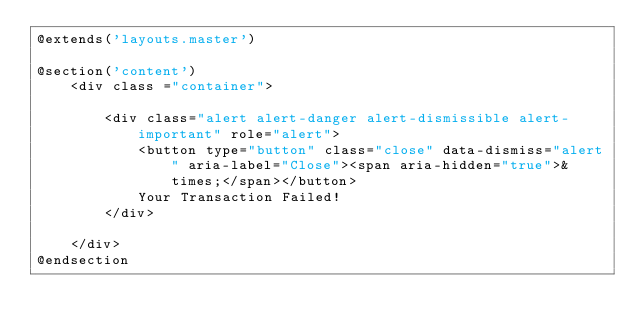<code> <loc_0><loc_0><loc_500><loc_500><_PHP_>@extends('layouts.master')

@section('content')
    <div class ="container">

        <div class="alert alert-danger alert-dismissible alert-important" role="alert">
            <button type="button" class="close" data-dismiss="alert" aria-label="Close"><span aria-hidden="true">&times;</span></button>
            Your Transaction Failed!
        </div>

    </div>
@endsection</code> 